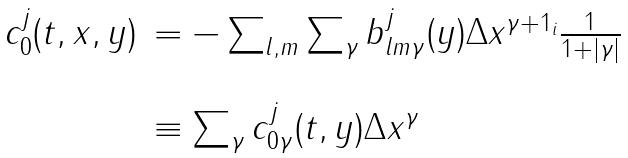Convert formula to latex. <formula><loc_0><loc_0><loc_500><loc_500>\begin{array} { l l } c ^ { j } _ { 0 } ( t , x , y ) & = - \sum _ { l , m } \sum _ { \gamma } b ^ { j } _ { l m \gamma } ( y ) \Delta x ^ { \gamma + 1 _ { i } } \frac { 1 } { 1 + | \gamma | } \\ \\ & \equiv \sum _ { \gamma } c ^ { j } _ { 0 \gamma } ( t , y ) \Delta x ^ { \gamma } \end{array}</formula> 